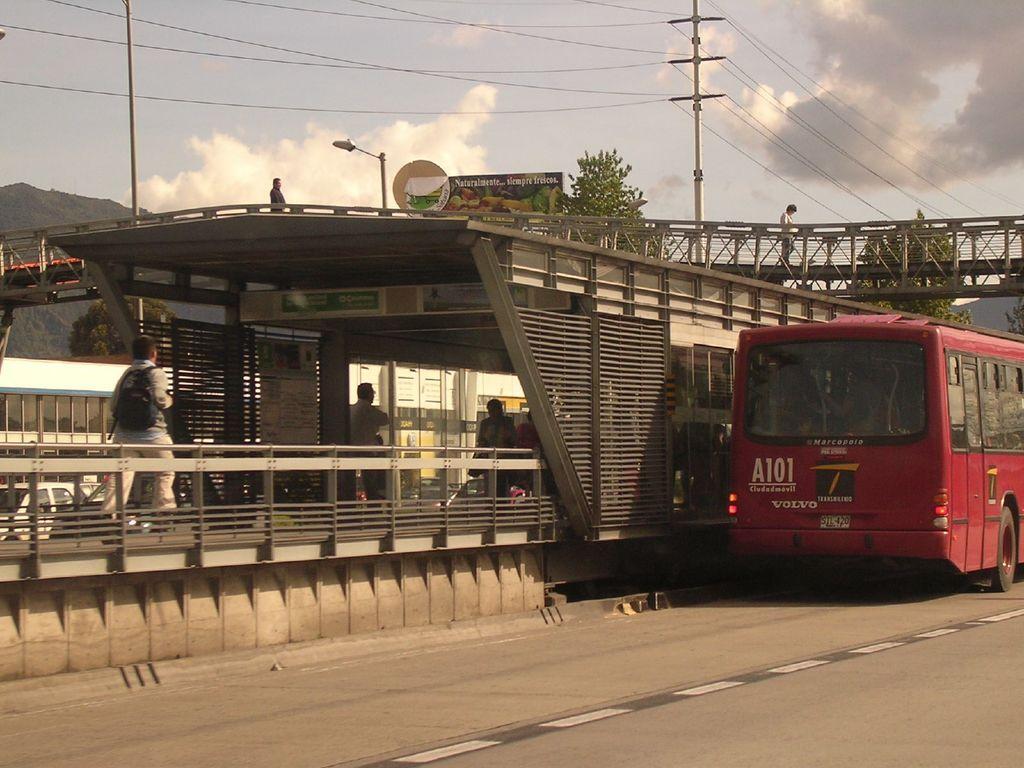In one or two sentences, can you explain what this image depicts? This picture is taken on the wide road. In this image, on the right side, we can see a bus which is in red color is placed on the road. On the left side, we can see a man wearing a backpack is walking. On the left side, we can also see a car. In the middle of the image, we can see two men. In the background, we can see buildings and a bridge, a person, hoardings, street light, electric pole, electric wires, trees, rocks. At the top, we can see a sky which is a bit cloudy, at the bottom, we can see a wide road. 